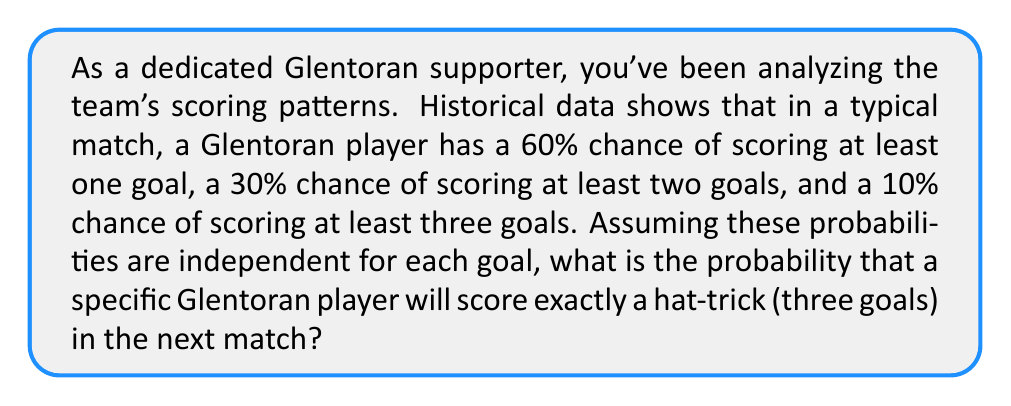Can you solve this math problem? Let's approach this step-by-step:

1) First, we need to understand what the given probabilities mean:
   - P(at least 1 goal) = 0.60
   - P(at least 2 goals) = 0.30
   - P(at least 3 goals) = 0.10

2) We want to find P(exactly 3 goals). This can be calculated as:
   P(exactly 3 goals) = P(at least 3 goals) - P(at least 4 goals)

3) We're given P(at least 3 goals) = 0.10, but we need to find P(at least 4 goals).

4) Assuming independence, we can use the given probabilities to calculate the probability of scoring each individual goal:

   Let $p$ be the probability of scoring a single goal.
   
   Then: $1 - (1-p)^3 = 0.60$
   
   Solving this: $p \approx 0.2679$

5) Now, the probability of scoring at least 4 goals is:
   
   $P(\text{at least 4 goals}) = 1 - P(0\text{ goals}) - P(1\text{ goal}) - P(2\text{ goals}) - P(3\text{ goals})$

   $= 1 - (1-p)^4 - \binom{4}{1}p(1-p)^3 - \binom{4}{2}p^2(1-p)^2 - \binom{4}{3}p^3(1-p)$

   $\approx 0.0284$

6) Therefore, the probability of scoring exactly 3 goals is:

   $P(\text{exactly 3 goals}) = P(\text{at least 3 goals}) - P(\text{at least 4 goals})$
   
   $= 0.10 - 0.0284 = 0.0716$
Answer: The probability that a specific Glentoran player will score exactly a hat-trick in the next match is approximately 0.0716 or 7.16%. 